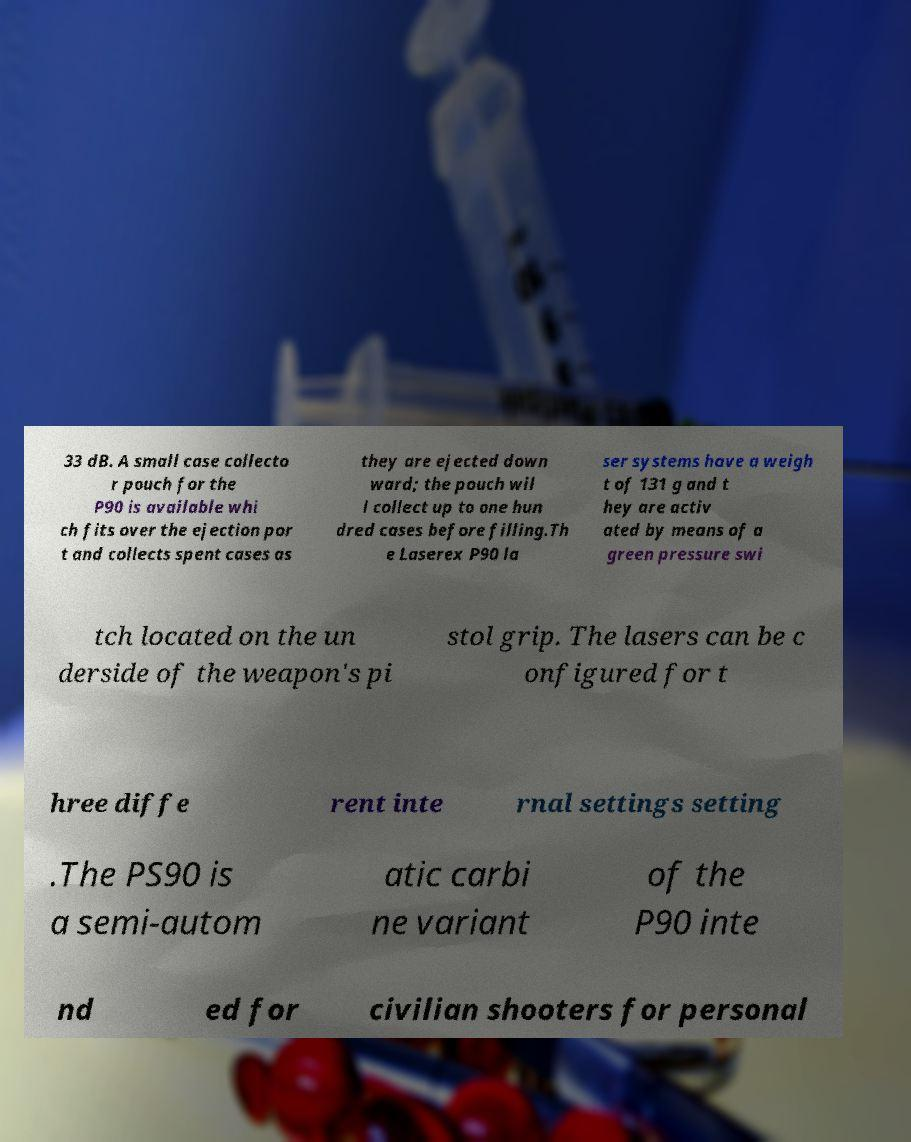There's text embedded in this image that I need extracted. Can you transcribe it verbatim? 33 dB. A small case collecto r pouch for the P90 is available whi ch fits over the ejection por t and collects spent cases as they are ejected down ward; the pouch wil l collect up to one hun dred cases before filling.Th e Laserex P90 la ser systems have a weigh t of 131 g and t hey are activ ated by means of a green pressure swi tch located on the un derside of the weapon's pi stol grip. The lasers can be c onfigured for t hree diffe rent inte rnal settings setting .The PS90 is a semi-autom atic carbi ne variant of the P90 inte nd ed for civilian shooters for personal 